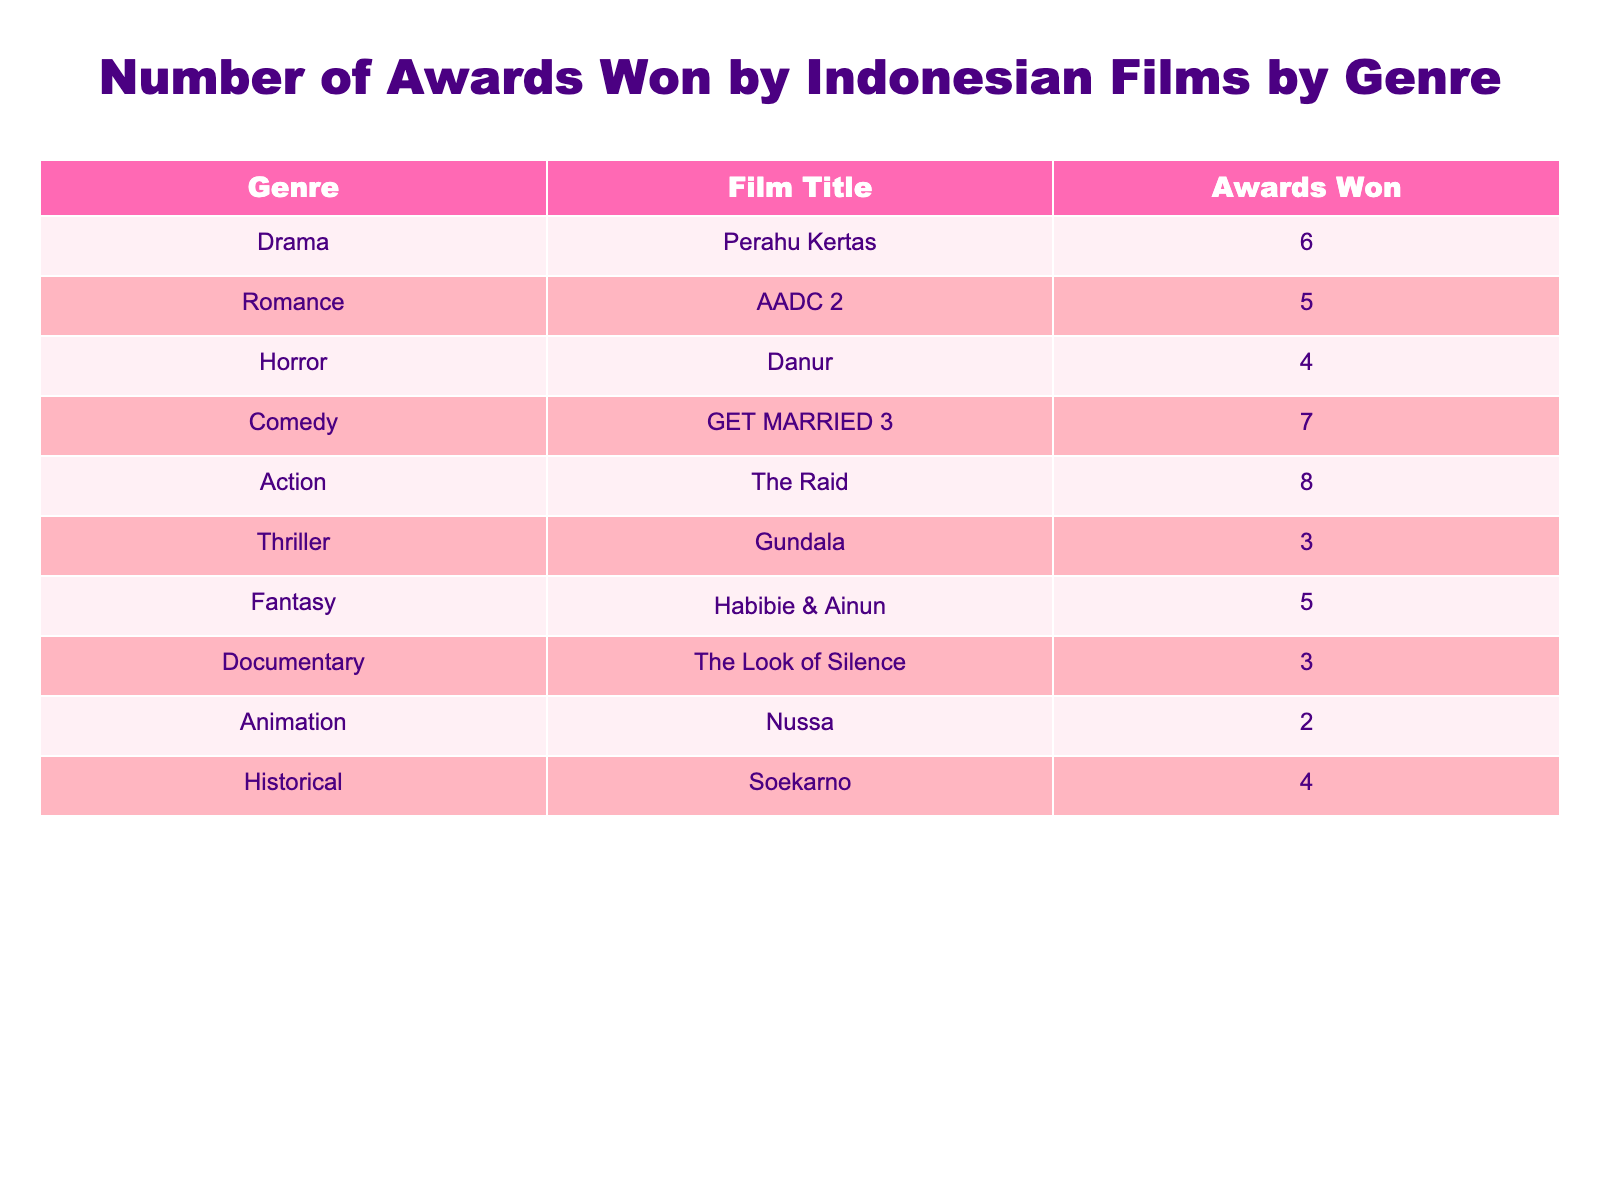What is the genre with the highest number of awards won? By examining the table, we can see that the Action genre (The Raid) has won 8 awards, which is more than any other genre listed.
Answer: Action How many awards did the film "AADC 2" win? The table specifies that "AADC 2" falls under the Romance genre and has won 5 awards.
Answer: 5 What is the total number of awards won by films in the Drama and Comedy genres? First, we find the awards for Drama (Perahu Kertas, 6 awards) and Comedy (GET MARRIED 3, 7 awards). Adding them together gives us 6 + 7 = 13 awards total.
Answer: 13 Did any documentary film win more than 3 awards? The table shows that "The Look of Silence," the only documentary listed, has won 3 awards. Therefore, the statement is false as no documentary has won more than this.
Answer: No What is the average number of awards won by the films listed in the Horror and Fantasy genres? The Horror genre (Danur) has won 4 awards and the Fantasy genre (Habibie & Ainun) has won 5 awards. To find the average, we sum these awards: 4 + 5 = 9, then divide by the number of genres (2) which gives 9/2 = 4.5.
Answer: 4.5 Which genre has the least number of awards won? Looking at the table, the Animation genre (Nussa) has won the least with only 2 awards, making it the genre with the fewest awards overall.
Answer: Animation How many genres have won more than 4 awards? From the table, we identify the genres with more than 4 awards: Drama (6), Comedy (7), Action (8), and Fantasy (5). In total, there are 4 genres that meet this criterion.
Answer: 4 Is "Danur" the only film listed in the Horror genre? The table lists only "Danur" under the Horror genre, indicating that it is indeed the sole film in that category.
Answer: Yes What is the difference in the number of awards won between the Action genre and the Animation genre? The Action genre has won 8 awards (The Raid) and the Animation genre has won 2 awards (Nussa). The difference is calculated as 8 - 2 = 6 awards.
Answer: 6 